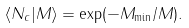Convert formula to latex. <formula><loc_0><loc_0><loc_500><loc_500>\langle N _ { c } | M \rangle = \exp ( - M _ { \min } / M ) .</formula> 